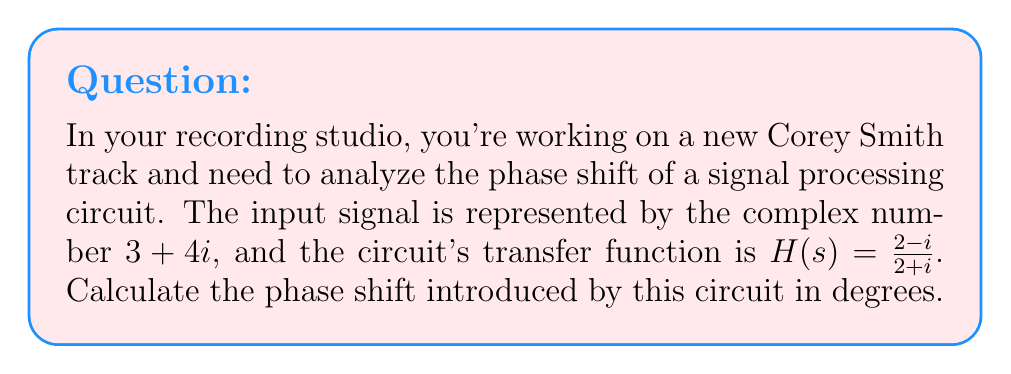Teach me how to tackle this problem. To solve this problem, we'll follow these steps:

1) The transfer function $H(s) = \frac{2-i}{2+i}$ represents how the circuit modifies the input signal. The phase shift is determined by the argument of this complex number.

2) To find the argument of $H(s)$, we need to convert it to polar form:

   $$H(s) = \frac{2-i}{2+i} = \frac{(2-i)(2-i)}{(2+i)(2-i)} = \frac{4+1-4i+i^2}{4+1+4i-i^2} = \frac{5-4i}{5+4i}$$

3) The magnitude of $H(s)$ is 1, as:

   $$|H(s)| = \sqrt{\frac{5^2+(-4)^2}{5^2+4^2}} = \sqrt{\frac{41}{41}} = 1$$

4) The argument of $H(s)$ is:

   $$\arg(H(s)) = \arctan(\frac{-4}{5}) - \arctan(\frac{4}{5})$$

5) Using the arctangent function:

   $$\arg(H(s)) = -\arctan(\frac{4}{5}) - \arctan(\frac{4}{5}) = -2\arctan(\frac{4}{5})$$

6) Calculate the value:

   $$\arg(H(s)) = -2 \arctan(\frac{4}{5}) \approx -0.7853981634 \text{ radians}$$

7) Convert to degrees:

   $$\text{Phase shift} = -0.7853981634 \times \frac{180^{\circ}}{\pi} \approx -45^{\circ}$$

The negative sign indicates that this is a phase lag.
Answer: The phase shift introduced by the circuit is approximately $-45^{\circ}$ (phase lag). 